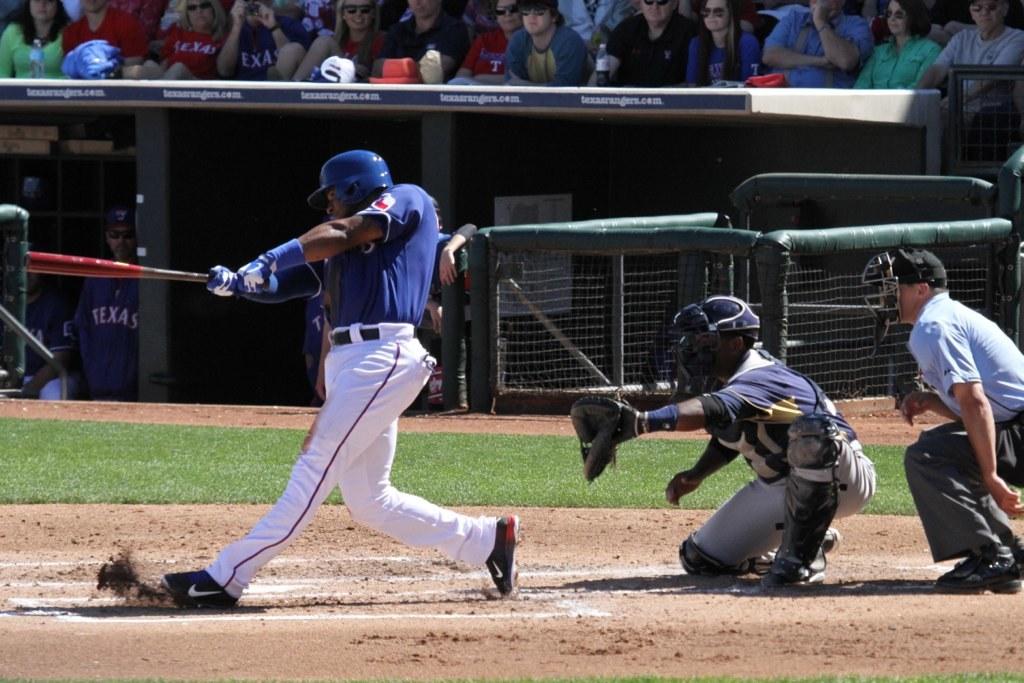What name is on the player in the dugout?
Your answer should be compact. Texas. 